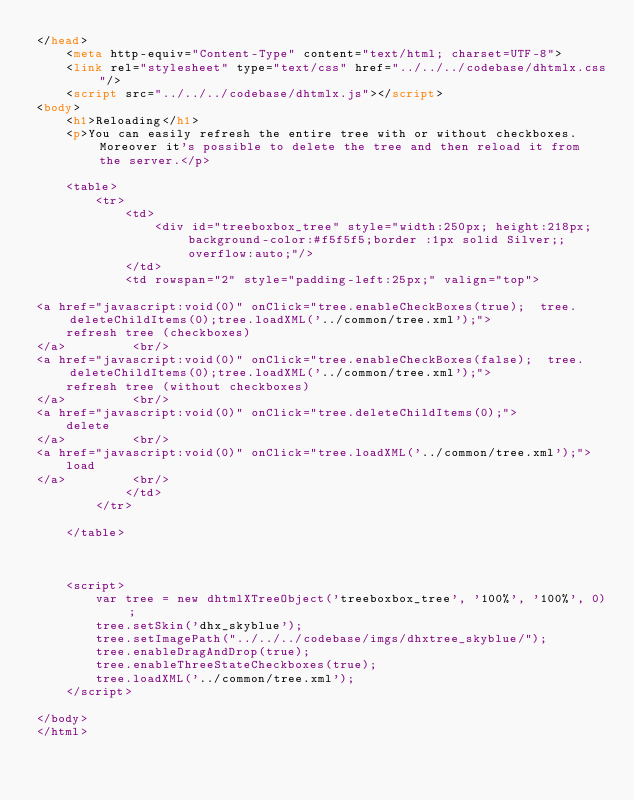<code> <loc_0><loc_0><loc_500><loc_500><_HTML_></head>
	<meta http-equiv="Content-Type" content="text/html; charset=UTF-8">
	<link rel="stylesheet" type="text/css" href="../../../codebase/dhtmlx.css"/>
	<script src="../../../codebase/dhtmlx.js"></script>
<body>
	<h1>Reloading</h1>
    <p>You can easily refresh the entire tree with or without checkboxes. Moreover it's possible to delete the tree and then reload it from the server.</p>
	
	<table>
		<tr>
			<td>
				<div id="treeboxbox_tree" style="width:250px; height:218px;background-color:#f5f5f5;border :1px solid Silver;; overflow:auto;"/>
			</td>
			<td rowspan="2" style="padding-left:25px;" valign="top">

<a href="javascript:void(0)" onClick="tree.enableCheckBoxes(true);  tree.deleteChildItems(0);tree.loadXML('../common/tree.xml');">
	refresh tree (checkboxes)
</a>         <br/>
<a href="javascript:void(0)" onClick="tree.enableCheckBoxes(false);  tree.deleteChildItems(0);tree.loadXML('../common/tree.xml');">
	refresh tree (without checkboxes)
</a>         <br/>
<a href="javascript:void(0)" onClick="tree.deleteChildItems(0);">
	delete
</a>         <br/>
<a href="javascript:void(0)" onClick="tree.loadXML('../common/tree.xml');">
	load
</a>         <br/>
			</td>
		</tr>
		
	</table>



	<script>
		var tree = new dhtmlXTreeObject('treeboxbox_tree', '100%', '100%', 0); 
		tree.setSkin('dhx_skyblue');
		tree.setImagePath("../../../codebase/imgs/dhxtree_skyblue/");
		tree.enableDragAndDrop(true);
		tree.enableThreeStateCheckboxes(true);
		tree.loadXML('../common/tree.xml');
	</script>
	
</body>
</html>
</code> 